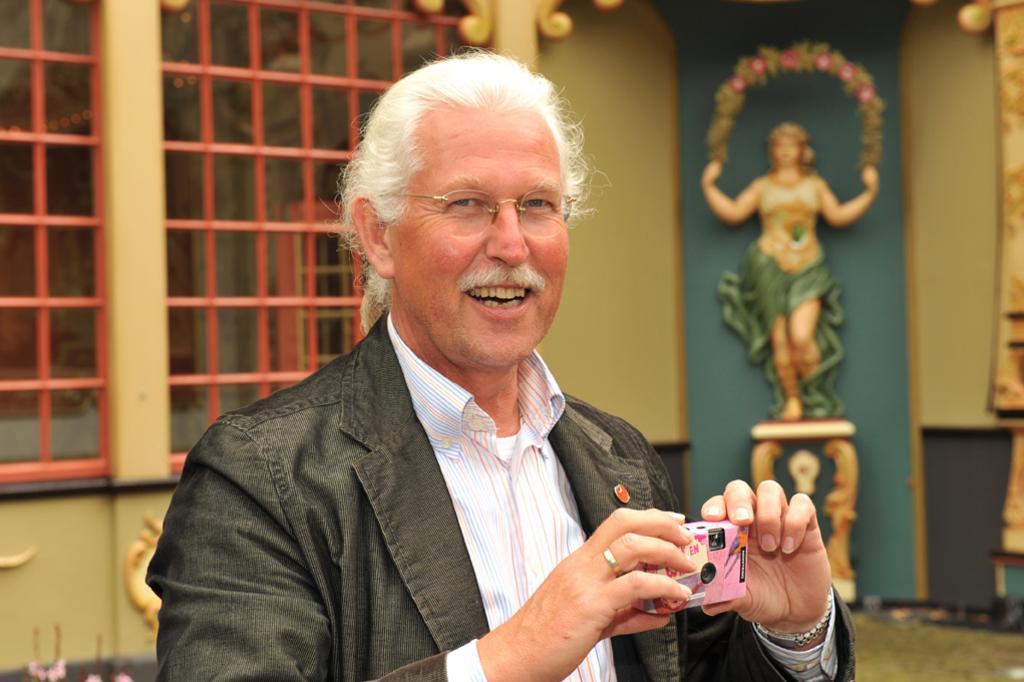How would you summarize this image in a sentence or two? In the image we can see there is a man who is standing and holding camera in his hand. 